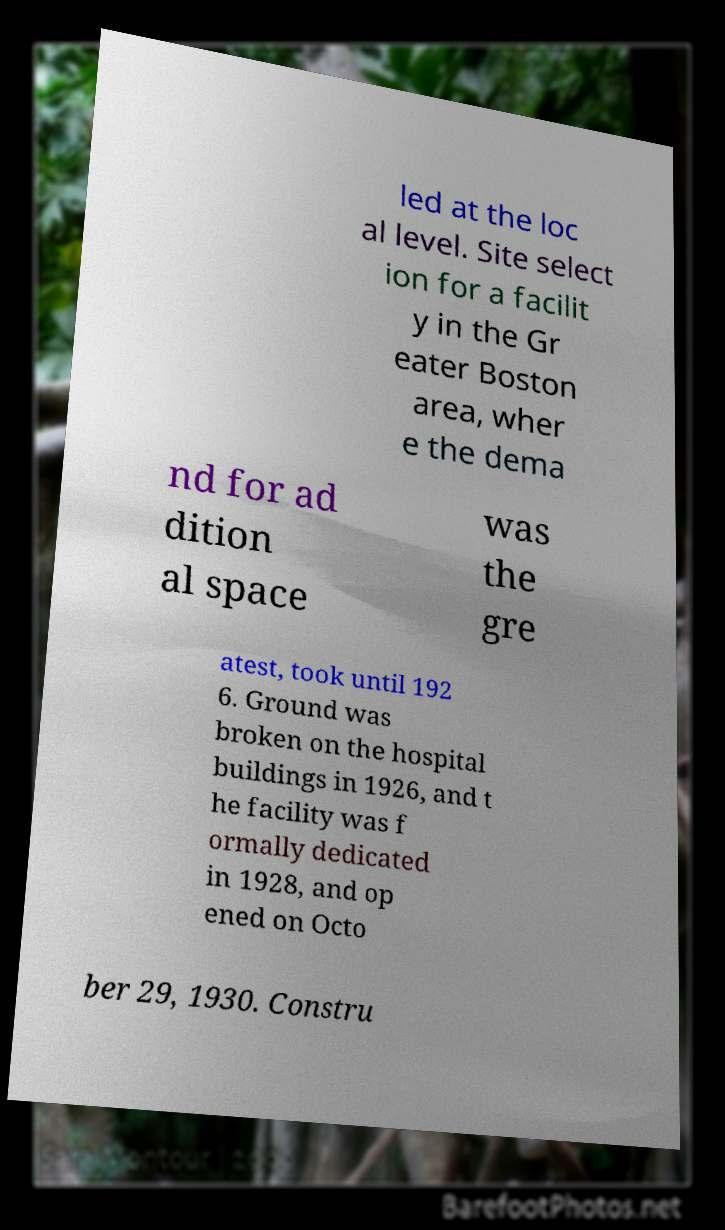Could you extract and type out the text from this image? led at the loc al level. Site select ion for a facilit y in the Gr eater Boston area, wher e the dema nd for ad dition al space was the gre atest, took until 192 6. Ground was broken on the hospital buildings in 1926, and t he facility was f ormally dedicated in 1928, and op ened on Octo ber 29, 1930. Constru 